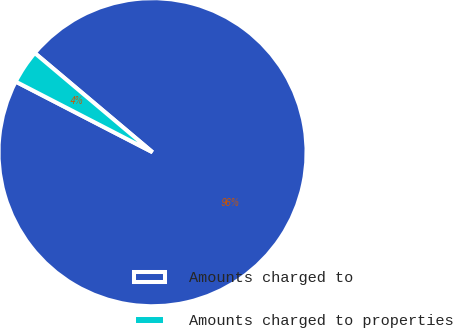Convert chart to OTSL. <chart><loc_0><loc_0><loc_500><loc_500><pie_chart><fcel>Amounts charged to<fcel>Amounts charged to properties<nl><fcel>96.44%<fcel>3.56%<nl></chart> 